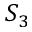Convert formula to latex. <formula><loc_0><loc_0><loc_500><loc_500>S _ { 3 }</formula> 